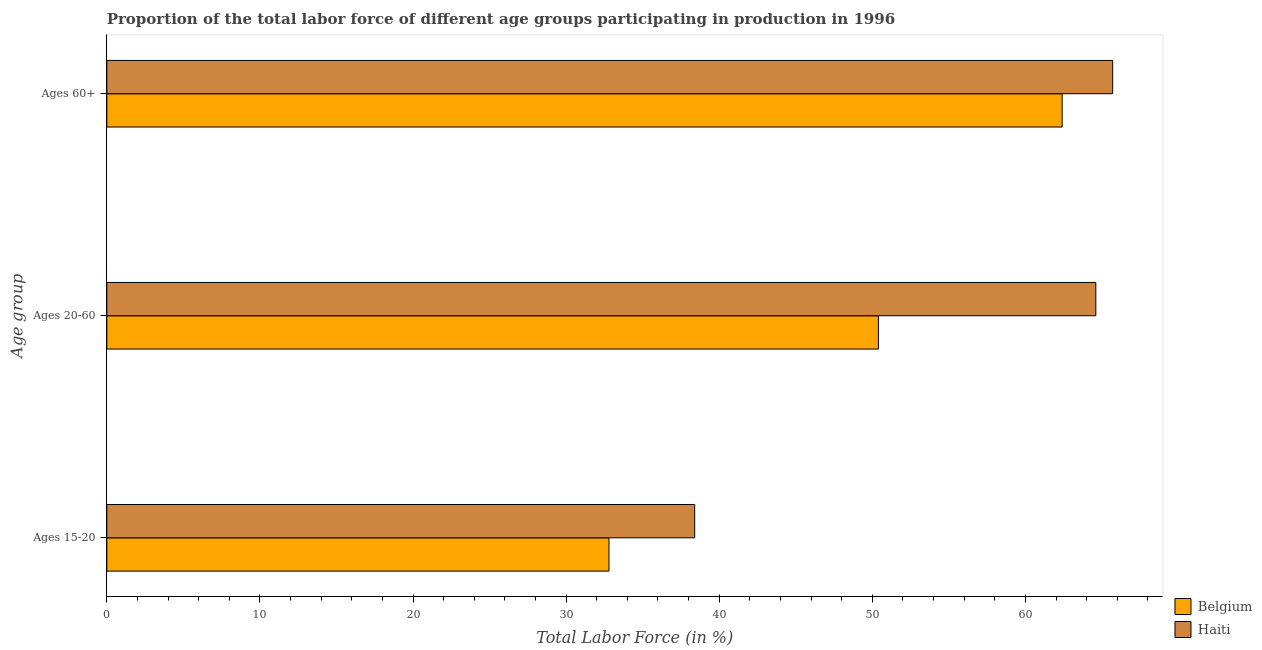How many different coloured bars are there?
Ensure brevity in your answer.  2. How many groups of bars are there?
Your answer should be very brief. 3. What is the label of the 3rd group of bars from the top?
Your answer should be very brief. Ages 15-20. What is the percentage of labor force within the age group 20-60 in Belgium?
Make the answer very short. 50.4. Across all countries, what is the maximum percentage of labor force within the age group 15-20?
Give a very brief answer. 38.4. Across all countries, what is the minimum percentage of labor force within the age group 20-60?
Offer a terse response. 50.4. In which country was the percentage of labor force within the age group 20-60 maximum?
Provide a short and direct response. Haiti. In which country was the percentage of labor force above age 60 minimum?
Provide a succinct answer. Belgium. What is the total percentage of labor force within the age group 20-60 in the graph?
Your response must be concise. 115. What is the difference between the percentage of labor force above age 60 in Belgium and that in Haiti?
Make the answer very short. -3.3. What is the average percentage of labor force within the age group 15-20 per country?
Keep it short and to the point. 35.6. What is the difference between the percentage of labor force within the age group 20-60 and percentage of labor force above age 60 in Haiti?
Ensure brevity in your answer.  -1.1. What is the ratio of the percentage of labor force within the age group 20-60 in Haiti to that in Belgium?
Give a very brief answer. 1.28. What is the difference between the highest and the second highest percentage of labor force within the age group 15-20?
Keep it short and to the point. 5.6. What is the difference between the highest and the lowest percentage of labor force within the age group 15-20?
Provide a succinct answer. 5.6. In how many countries, is the percentage of labor force within the age group 15-20 greater than the average percentage of labor force within the age group 15-20 taken over all countries?
Your answer should be compact. 1. Is the sum of the percentage of labor force within the age group 15-20 in Belgium and Haiti greater than the maximum percentage of labor force within the age group 20-60 across all countries?
Offer a terse response. Yes. What does the 2nd bar from the top in Ages 20-60 represents?
Your answer should be compact. Belgium. What does the 2nd bar from the bottom in Ages 60+ represents?
Offer a very short reply. Haiti. Is it the case that in every country, the sum of the percentage of labor force within the age group 15-20 and percentage of labor force within the age group 20-60 is greater than the percentage of labor force above age 60?
Provide a short and direct response. Yes. How many bars are there?
Offer a very short reply. 6. Are the values on the major ticks of X-axis written in scientific E-notation?
Provide a short and direct response. No. Where does the legend appear in the graph?
Make the answer very short. Bottom right. How many legend labels are there?
Give a very brief answer. 2. How are the legend labels stacked?
Keep it short and to the point. Vertical. What is the title of the graph?
Provide a succinct answer. Proportion of the total labor force of different age groups participating in production in 1996. What is the label or title of the Y-axis?
Provide a succinct answer. Age group. What is the Total Labor Force (in %) of Belgium in Ages 15-20?
Your answer should be compact. 32.8. What is the Total Labor Force (in %) in Haiti in Ages 15-20?
Provide a succinct answer. 38.4. What is the Total Labor Force (in %) of Belgium in Ages 20-60?
Keep it short and to the point. 50.4. What is the Total Labor Force (in %) in Haiti in Ages 20-60?
Your answer should be very brief. 64.6. What is the Total Labor Force (in %) of Belgium in Ages 60+?
Provide a succinct answer. 62.4. What is the Total Labor Force (in %) of Haiti in Ages 60+?
Ensure brevity in your answer.  65.7. Across all Age group, what is the maximum Total Labor Force (in %) in Belgium?
Your response must be concise. 62.4. Across all Age group, what is the maximum Total Labor Force (in %) in Haiti?
Provide a short and direct response. 65.7. Across all Age group, what is the minimum Total Labor Force (in %) in Belgium?
Give a very brief answer. 32.8. Across all Age group, what is the minimum Total Labor Force (in %) in Haiti?
Your answer should be compact. 38.4. What is the total Total Labor Force (in %) of Belgium in the graph?
Make the answer very short. 145.6. What is the total Total Labor Force (in %) in Haiti in the graph?
Offer a very short reply. 168.7. What is the difference between the Total Labor Force (in %) in Belgium in Ages 15-20 and that in Ages 20-60?
Provide a short and direct response. -17.6. What is the difference between the Total Labor Force (in %) of Haiti in Ages 15-20 and that in Ages 20-60?
Provide a succinct answer. -26.2. What is the difference between the Total Labor Force (in %) of Belgium in Ages 15-20 and that in Ages 60+?
Keep it short and to the point. -29.6. What is the difference between the Total Labor Force (in %) of Haiti in Ages 15-20 and that in Ages 60+?
Your answer should be compact. -27.3. What is the difference between the Total Labor Force (in %) in Belgium in Ages 20-60 and that in Ages 60+?
Your answer should be very brief. -12. What is the difference between the Total Labor Force (in %) in Belgium in Ages 15-20 and the Total Labor Force (in %) in Haiti in Ages 20-60?
Your answer should be compact. -31.8. What is the difference between the Total Labor Force (in %) of Belgium in Ages 15-20 and the Total Labor Force (in %) of Haiti in Ages 60+?
Your answer should be compact. -32.9. What is the difference between the Total Labor Force (in %) in Belgium in Ages 20-60 and the Total Labor Force (in %) in Haiti in Ages 60+?
Provide a succinct answer. -15.3. What is the average Total Labor Force (in %) of Belgium per Age group?
Offer a terse response. 48.53. What is the average Total Labor Force (in %) of Haiti per Age group?
Offer a very short reply. 56.23. What is the difference between the Total Labor Force (in %) in Belgium and Total Labor Force (in %) in Haiti in Ages 15-20?
Offer a terse response. -5.6. What is the difference between the Total Labor Force (in %) in Belgium and Total Labor Force (in %) in Haiti in Ages 20-60?
Ensure brevity in your answer.  -14.2. What is the difference between the Total Labor Force (in %) of Belgium and Total Labor Force (in %) of Haiti in Ages 60+?
Provide a succinct answer. -3.3. What is the ratio of the Total Labor Force (in %) of Belgium in Ages 15-20 to that in Ages 20-60?
Your response must be concise. 0.65. What is the ratio of the Total Labor Force (in %) in Haiti in Ages 15-20 to that in Ages 20-60?
Your answer should be compact. 0.59. What is the ratio of the Total Labor Force (in %) in Belgium in Ages 15-20 to that in Ages 60+?
Keep it short and to the point. 0.53. What is the ratio of the Total Labor Force (in %) of Haiti in Ages 15-20 to that in Ages 60+?
Provide a short and direct response. 0.58. What is the ratio of the Total Labor Force (in %) of Belgium in Ages 20-60 to that in Ages 60+?
Offer a terse response. 0.81. What is the ratio of the Total Labor Force (in %) of Haiti in Ages 20-60 to that in Ages 60+?
Keep it short and to the point. 0.98. What is the difference between the highest and the second highest Total Labor Force (in %) of Belgium?
Provide a short and direct response. 12. What is the difference between the highest and the lowest Total Labor Force (in %) of Belgium?
Provide a short and direct response. 29.6. What is the difference between the highest and the lowest Total Labor Force (in %) in Haiti?
Provide a short and direct response. 27.3. 